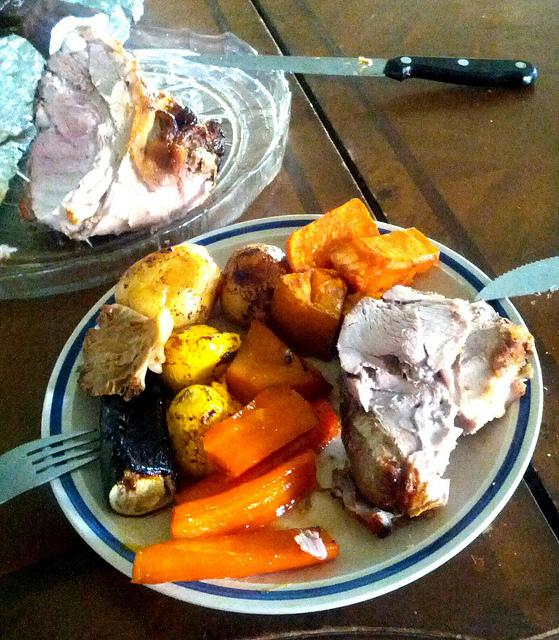How have these vegetables been cooked?

Choices:
A) roasted
B) fried
C) baked
D) boiled roasted 